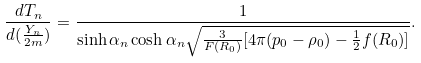<formula> <loc_0><loc_0><loc_500><loc_500>\frac { d T _ { n } } { d ( \frac { Y _ { n } } { 2 m } ) } = \frac { 1 } { \sinh \alpha _ { n } \cosh \alpha _ { n } { \sqrt { \frac { 3 } { F ( R _ { 0 } ) } [ 4 \pi ( p _ { 0 } - \rho _ { 0 } ) - \frac { 1 } { 2 } f ( R _ { 0 } ) ] } } } .</formula> 